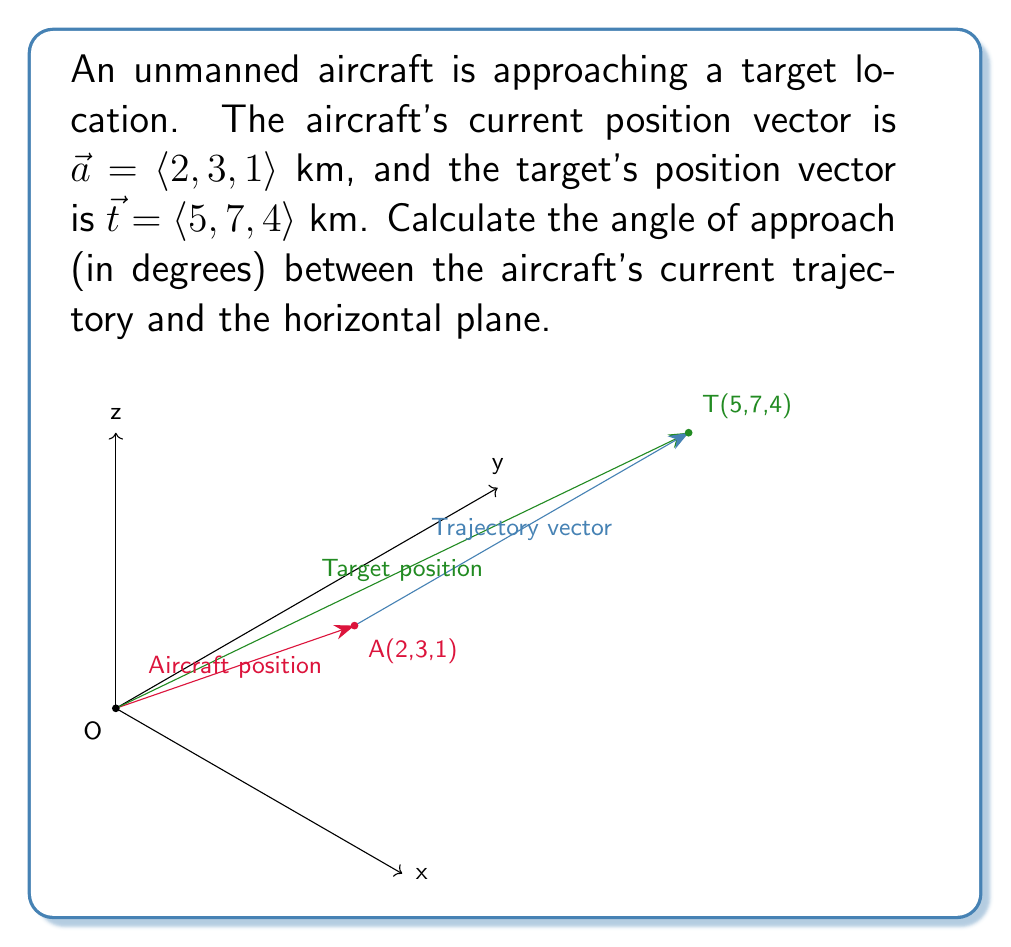Provide a solution to this math problem. To solve this problem, we'll follow these steps:

1) First, we need to find the trajectory vector $\vec{v}$ from the aircraft to the target:
   $$\vec{v} = \vec{t} - \vec{a} = \langle 5-2, 7-3, 4-1 \rangle = \langle 3, 4, 3 \rangle$$ km

2) The angle of approach is the angle between this trajectory vector and its projection onto the horizontal (xy) plane. We can find this using the dot product formula:
   $$\cos \theta = \frac{\vec{v} \cdot \vec{k}}{|\vec{v}||\vec{k}|}$$
   where $\vec{k}$ is the unit vector in the z-direction $\langle 0, 0, 1 \rangle$.

3) Calculate the magnitude of $\vec{v}$:
   $$|\vec{v}| = \sqrt{3^2 + 4^2 + 3^2} = \sqrt{34}$$ km

4) Calculate the dot product $\vec{v} \cdot \vec{k}$:
   $$\vec{v} \cdot \vec{k} = 3 \cdot 0 + 4 \cdot 0 + 3 \cdot 1 = 3$$ km

5) Substitute into the formula:
   $$\cos \theta = \frac{3}{\sqrt{34} \cdot 1} = \frac{3}{\sqrt{34}}$$

6) Take the inverse cosine (arccos) of both sides:
   $$\theta = \arccos(\frac{3}{\sqrt{34}})$$

7) Convert to degrees:
   $$\theta = \arccos(\frac{3}{\sqrt{34}}) \cdot \frac{180}{\pi} \approx 59.2°$$

The angle of approach is approximately 59.2 degrees.
Answer: $59.2°$ 